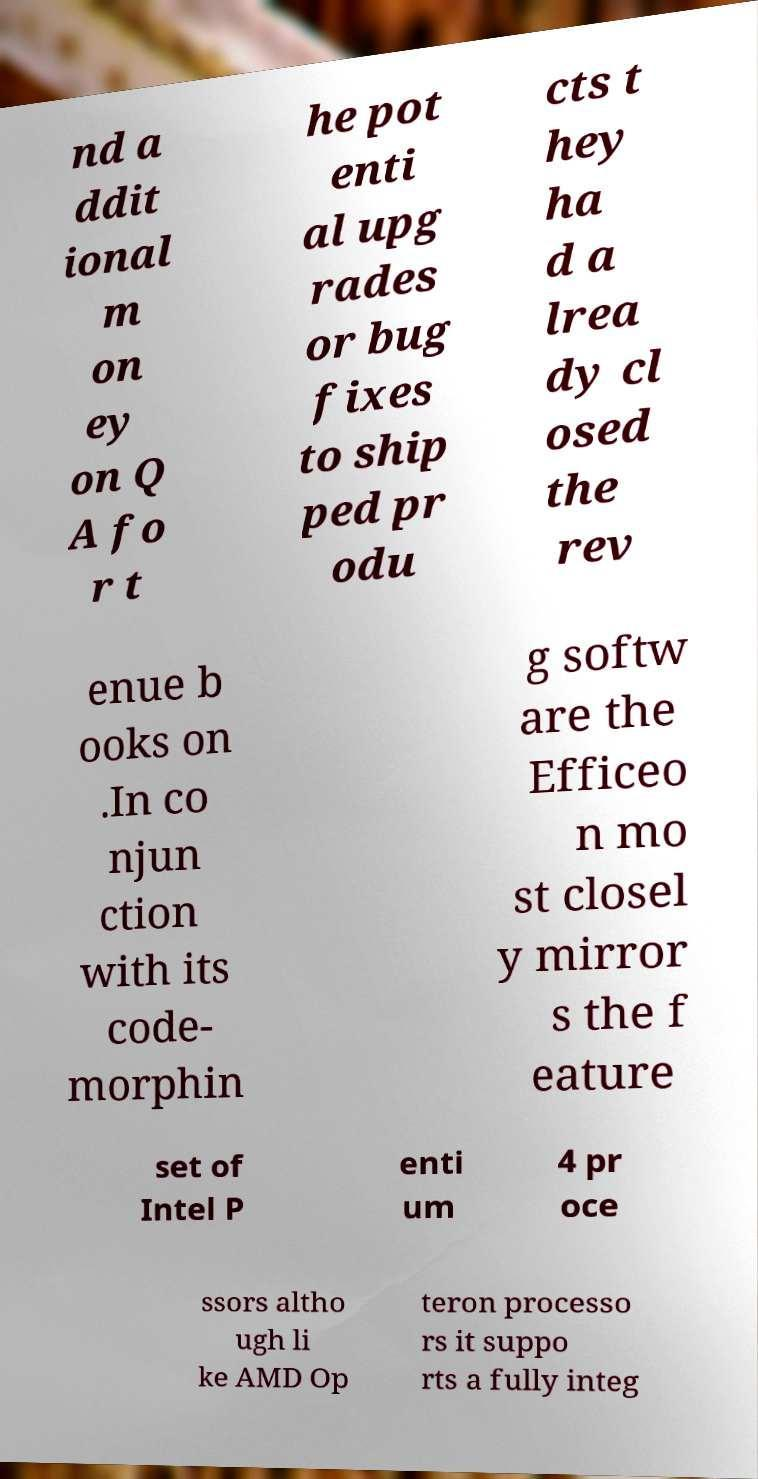For documentation purposes, I need the text within this image transcribed. Could you provide that? nd a ddit ional m on ey on Q A fo r t he pot enti al upg rades or bug fixes to ship ped pr odu cts t hey ha d a lrea dy cl osed the rev enue b ooks on .In co njun ction with its code- morphin g softw are the Efficeo n mo st closel y mirror s the f eature set of Intel P enti um 4 pr oce ssors altho ugh li ke AMD Op teron processo rs it suppo rts a fully integ 